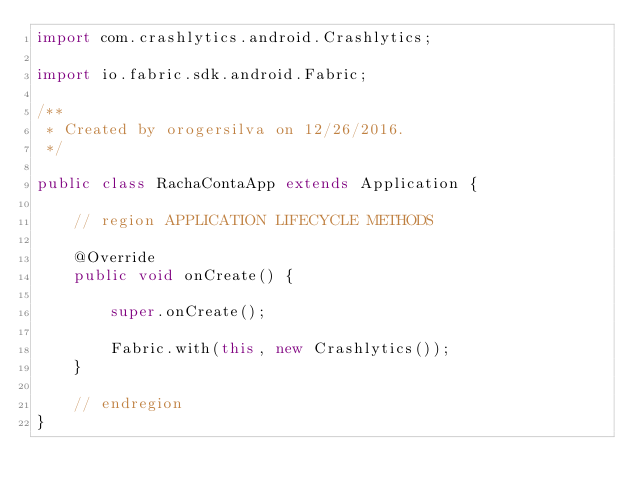<code> <loc_0><loc_0><loc_500><loc_500><_Java_>import com.crashlytics.android.Crashlytics;

import io.fabric.sdk.android.Fabric;

/**
 * Created by orogersilva on 12/26/2016.
 */

public class RachaContaApp extends Application {

    // region APPLICATION LIFECYCLE METHODS

    @Override
    public void onCreate() {

        super.onCreate();

        Fabric.with(this, new Crashlytics());
    }

    // endregion
}
</code> 